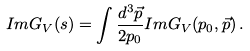Convert formula to latex. <formula><loc_0><loc_0><loc_500><loc_500>I m G _ { V } ( s ) = \int \frac { d ^ { 3 } \vec { p } } { 2 p _ { 0 } } I m G _ { V } ( p _ { 0 } , \vec { p } ) \, .</formula> 